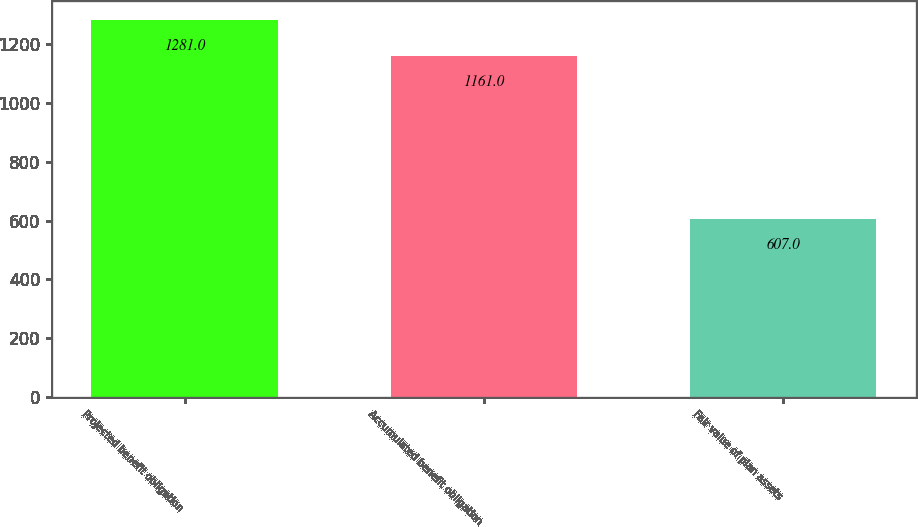Convert chart. <chart><loc_0><loc_0><loc_500><loc_500><bar_chart><fcel>Projected benefit obligation<fcel>Accumulated benefit obligation<fcel>Fair value of plan assets<nl><fcel>1281<fcel>1161<fcel>607<nl></chart> 